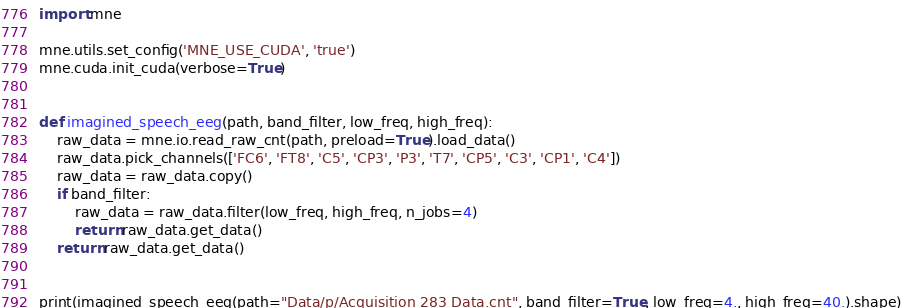Convert code to text. <code><loc_0><loc_0><loc_500><loc_500><_Python_>import mne

mne.utils.set_config('MNE_USE_CUDA', 'true')
mne.cuda.init_cuda(verbose=True)


def imagined_speech_eeg(path, band_filter, low_freq, high_freq):
    raw_data = mne.io.read_raw_cnt(path, preload=True).load_data()
    raw_data.pick_channels(['FC6', 'FT8', 'C5', 'CP3', 'P3', 'T7', 'CP5', 'C3', 'CP1', 'C4'])
    raw_data = raw_data.copy()
    if band_filter:
        raw_data = raw_data.filter(low_freq, high_freq, n_jobs=4)
        return raw_data.get_data()
    return raw_data.get_data()


print(imagined_speech_eeg(path="Data/p/Acquisition 283 Data.cnt", band_filter=True, low_freq=4., high_freq=40.).shape)


</code> 